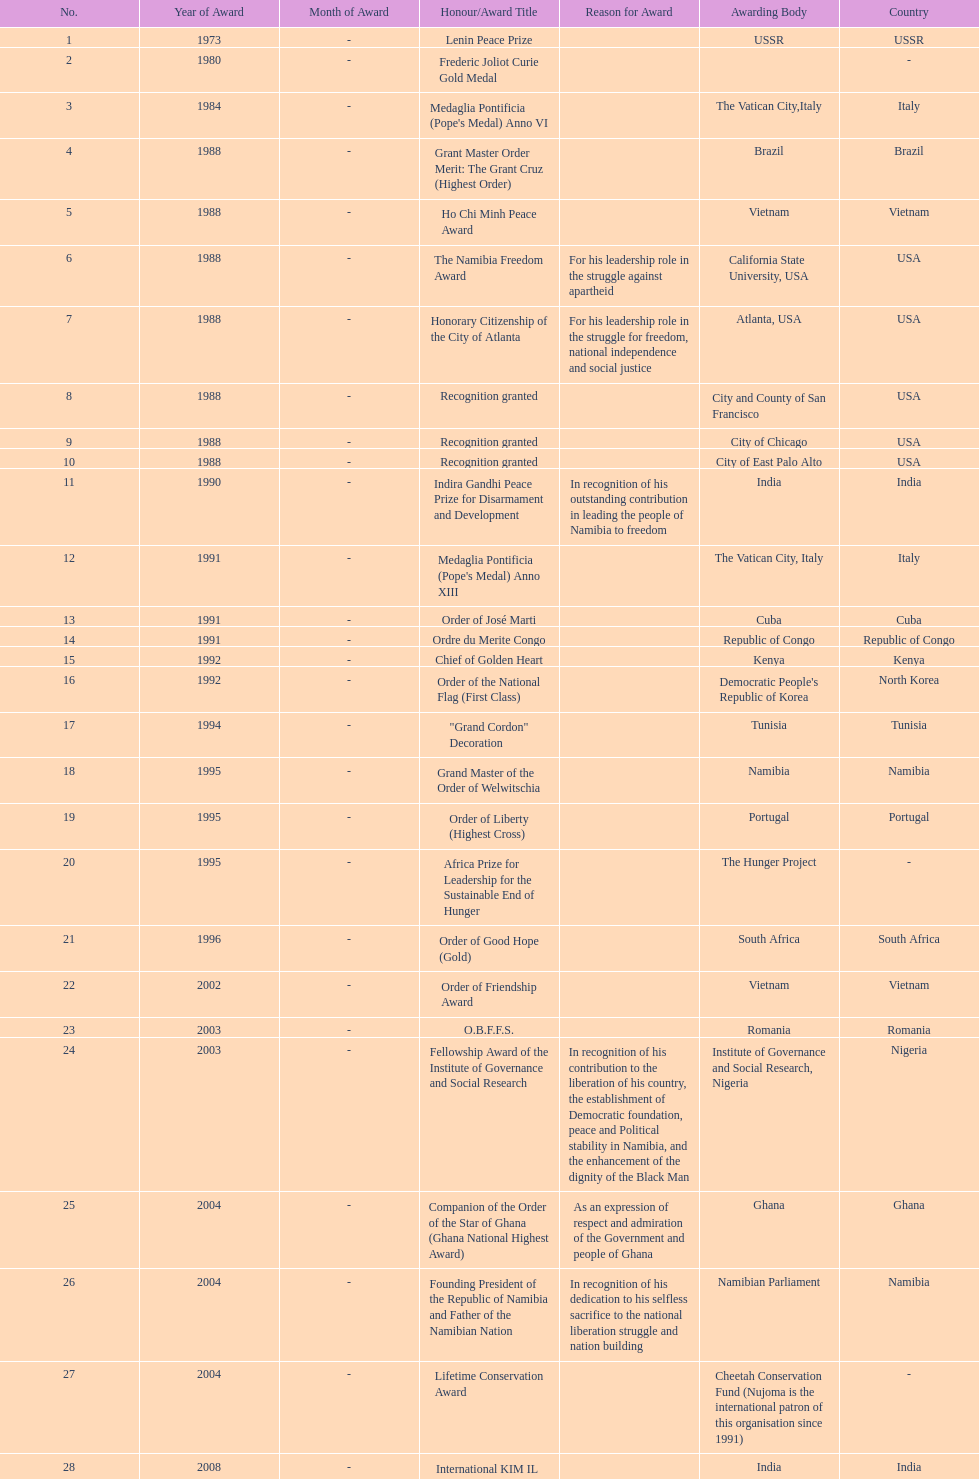Did nujoma win the o.b.f.f.s. award in romania or ghana? Romania. Parse the table in full. {'header': ['No.', 'Year of Award', 'Month of Award', 'Honour/Award Title', 'Reason for Award', 'Awarding Body', 'Country'], 'rows': [['1', '1973', '-', 'Lenin Peace Prize', '', 'USSR', 'USSR'], ['2', '1980', '-', 'Frederic Joliot Curie Gold Medal', '', '', '-'], ['3', '1984', '-', "Medaglia Pontificia (Pope's Medal) Anno VI", '', 'The Vatican City,Italy', 'Italy'], ['4', '1988', '-', 'Grant Master Order Merit: The Grant Cruz (Highest Order)', '', 'Brazil', 'Brazil'], ['5', '1988', '-', 'Ho Chi Minh Peace Award', '', 'Vietnam', 'Vietnam'], ['6', '1988', '-', 'The Namibia Freedom Award', 'For his leadership role in the struggle against apartheid', 'California State University, USA', 'USA'], ['7', '1988', '-', 'Honorary Citizenship of the City of Atlanta', 'For his leadership role in the struggle for freedom, national independence and social justice', 'Atlanta, USA', 'USA'], ['8', '1988', '-', 'Recognition granted', '', 'City and County of San Francisco', 'USA'], ['9', '1988', '-', 'Recognition granted', '', 'City of Chicago', 'USA'], ['10', '1988', '-', 'Recognition granted', '', 'City of East Palo Alto', 'USA'], ['11', '1990', '-', 'Indira Gandhi Peace Prize for Disarmament and Development', 'In recognition of his outstanding contribution in leading the people of Namibia to freedom', 'India', 'India'], ['12', '1991', '-', "Medaglia Pontificia (Pope's Medal) Anno XIII", '', 'The Vatican City, Italy', 'Italy'], ['13', '1991', '-', 'Order of José Marti', '', 'Cuba', 'Cuba'], ['14', '1991', '-', 'Ordre du Merite Congo', '', 'Republic of Congo', 'Republic of Congo'], ['15', '1992', '-', 'Chief of Golden Heart', '', 'Kenya', 'Kenya'], ['16', '1992', '-', 'Order of the National Flag (First Class)', '', "Democratic People's Republic of Korea", 'North Korea'], ['17', '1994', '-', '"Grand Cordon" Decoration', '', 'Tunisia', 'Tunisia'], ['18', '1995', '-', 'Grand Master of the Order of Welwitschia', '', 'Namibia', 'Namibia'], ['19', '1995', '-', 'Order of Liberty (Highest Cross)', '', 'Portugal', 'Portugal'], ['20', '1995', '-', 'Africa Prize for Leadership for the Sustainable End of Hunger', '', 'The Hunger Project', '-'], ['21', '1996', '-', 'Order of Good Hope (Gold)', '', 'South Africa', 'South Africa'], ['22', '2002', '-', 'Order of Friendship Award', '', 'Vietnam', 'Vietnam'], ['23', '2003', '-', 'O.B.F.F.S.', '', 'Romania', 'Romania'], ['24', '2003', '-', 'Fellowship Award of the Institute of Governance and Social Research', 'In recognition of his contribution to the liberation of his country, the establishment of Democratic foundation, peace and Political stability in Namibia, and the enhancement of the dignity of the Black Man', 'Institute of Governance and Social Research, Nigeria', 'Nigeria'], ['25', '2004', '-', 'Companion of the Order of the Star of Ghana (Ghana National Highest Award)', 'As an expression of respect and admiration of the Government and people of Ghana', 'Ghana', 'Ghana'], ['26', '2004', '-', 'Founding President of the Republic of Namibia and Father of the Namibian Nation', 'In recognition of his dedication to his selfless sacrifice to the national liberation struggle and nation building', 'Namibian Parliament', 'Namibia'], ['27', '2004', '-', 'Lifetime Conservation Award', '', 'Cheetah Conservation Fund (Nujoma is the international patron of this organisation since 1991)', '-'], ['28', '2008', '-', 'International KIM IL Sung Prize Certificate', '', 'India', 'India'], ['29', '2010', '-', 'Sir Seretse Khama SADC Meda', '', 'SADC', 'SADC']]} 